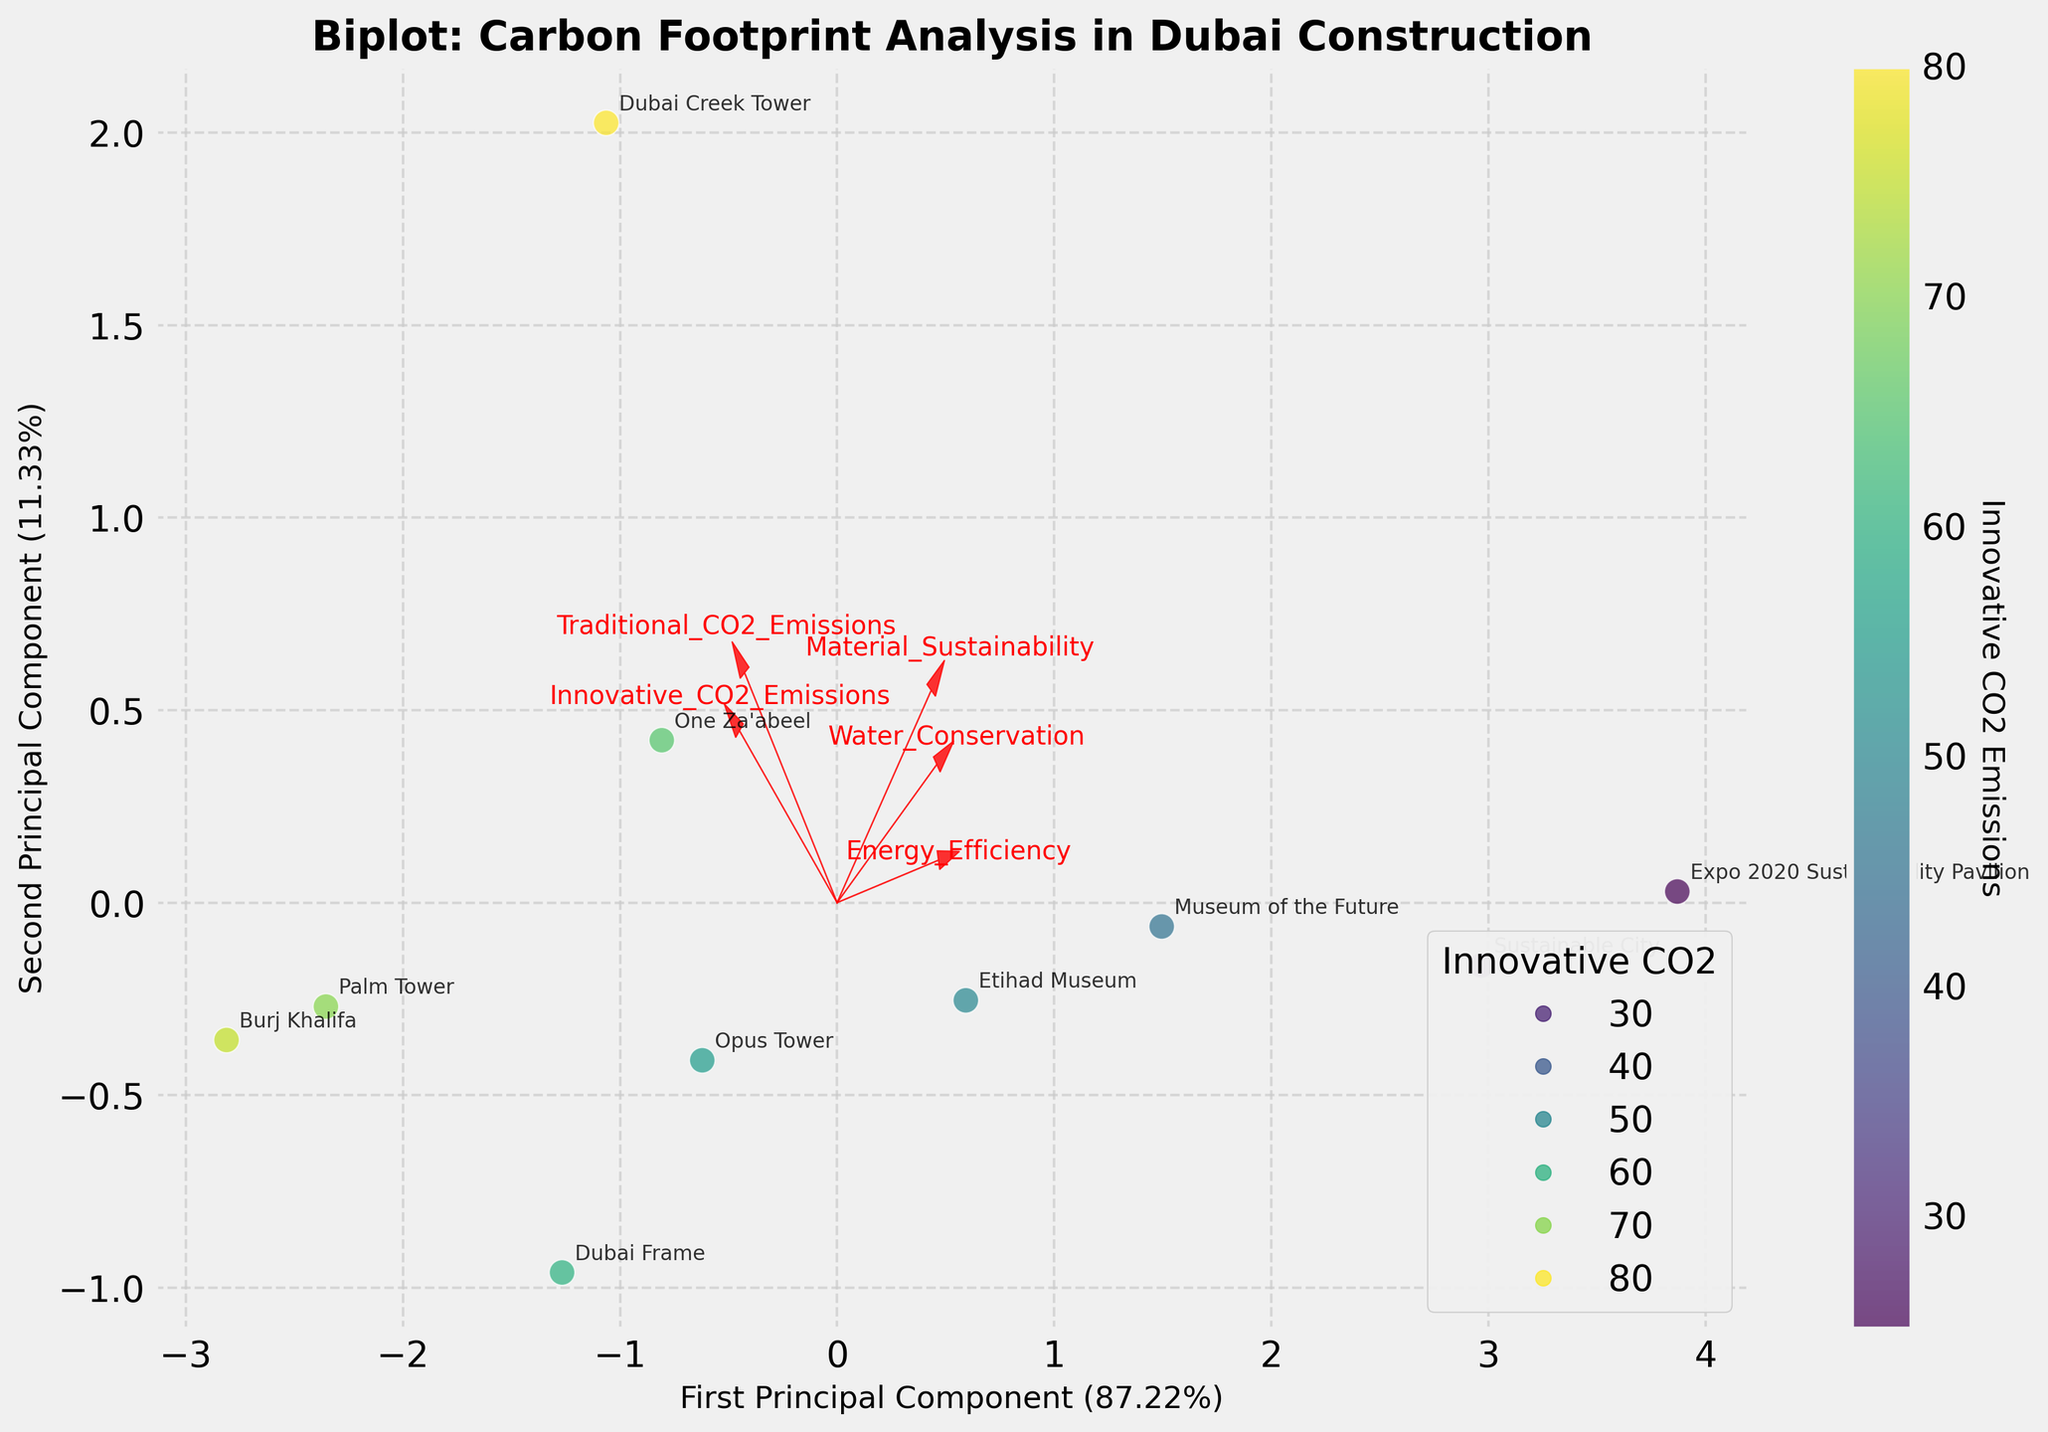What is the title of the plot? The title is located at the top of the plot.
Answer: Biplot: Carbon Footprint Analysis in Dubai Construction How many data points are represented in the plot? Each data point corresponds to a project labeled on the plot, with each labeled point representing a data point. Count these labels to find the total number.
Answer: 10 Which project has the highest Innovative CO2 Emissions? The color intensity represents the value of Innovative CO2 Emissions. The most intense color indicates the highest emission.
Answer: Dubai Creek Tower Which principal component represents more variance, the first or the second? Check the axis labels for the percentage of variance explained by each principal component. Compare the percentages.
Answer: First Principal Component What are the names of the projects that have lower Innovative CO2 Emissions than Traditional CO2 Emissions? Identify the color intensity relative to the position of 'Innovative_CO2_Emissions' vector and compare the projects accordingly.
Answer: Burj Khalifa, Dubai Frame, Museum of the Future, Opus Tower, Sustainable City, One Za'abeel, Etihad Museum, Palm Tower, Dubai Creek Tower, Expo 2020 Sustainability Pavilion How does the Sustainability Pavilion perform in terms of Water Conservation compared to the Burj Khalifa? Locate both project labels and examine their relative positions to the 'Water_Conservation' vector. The project closer to the vector has better performance.
Answer: Sustainability Pavilion has better water conservation than Burj Khalifa Which feature vector points in approximately the same direction as Material Sustainability? Check which listed feature vectors have a similar direction and angle to Material Sustainability in the biplot.
Answer: Innovative CO2 Emissions What two attributes are represented by the components of the feature vector closest to the y-axis? Identify the feature vectors that lie closest to the y-axis and read their labels.
Answer: Energy Efficiency and Water Conservation Compare the performance of Dubai Frame and Etihad Museum in terms of Energy Efficiency. Find both projects on the plot and note their positions relative to the 'Energy_Efficiency' vector.
Answer: Etihad Museum has better energy efficiency than Dubai Frame 